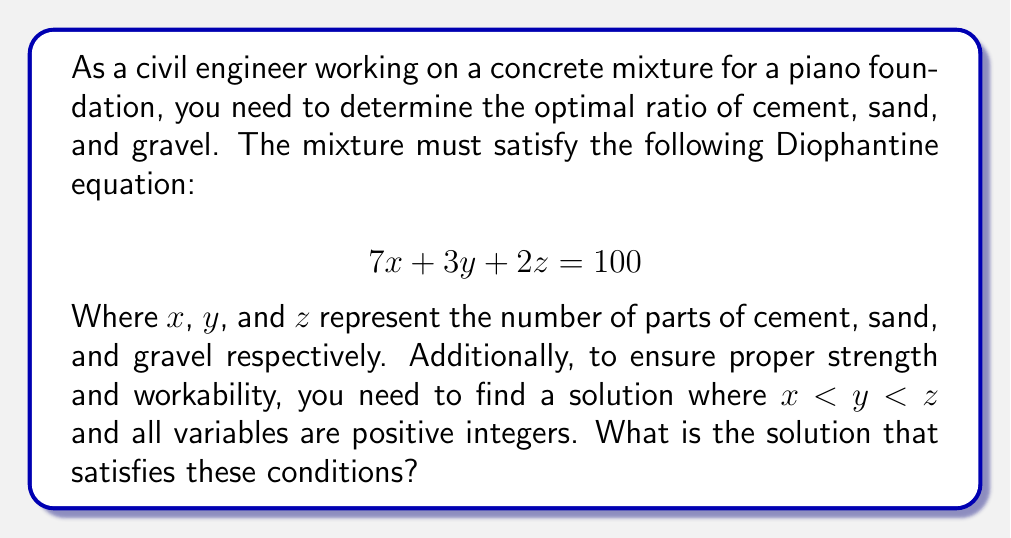What is the answer to this math problem? To solve this Diophantine equation with the given constraints, we can follow these steps:

1) First, note that $x$, $y$, and $z$ must be positive integers, and $x < y < z$.

2) Since $7x + 3y + 2z = 100$, and all terms are positive, each variable must be less than 100.

3) We can start by considering the possible values for $x$. Since $7x$ must be less than 100, $x$ can be at most 14.

4) Now, we can iterate through possible values of $x$ from 1 to 14:

   For $x = 1$: $7(1) + 3y + 2z = 100$ $\Rightarrow$ $3y + 2z = 93$
   For $x = 2$: $7(2) + 3y + 2z = 100$ $\Rightarrow$ $3y + 2z = 86$
   ...
   For $x = 14$: $7(14) + 3y + 2z = 100$ $\Rightarrow$ $3y + 2z = 2$ (impossible as $y$ and $z$ are positive)

5) For each of these equations, we need to find integer solutions for $y$ and $z$ where $y < z$.

6) After checking all possibilities, we find that when $x = 4$, we have:
   
   $7(4) + 3y + 2z = 100$
   $28 + 3y + 2z = 100$
   $3y + 2z = 72$

7) This equation has a solution that satisfies our conditions: $y = 8$ and $z = 24$

8) We can verify:
   $7(4) + 3(8) + 2(24) = 28 + 24 + 48 = 100$

9) This solution satisfies all conditions: $x = 4 < y = 8 < z = 24$, and all are positive integers.
Answer: The solution is $x = 4$, $y = 8$, and $z = 24$. 